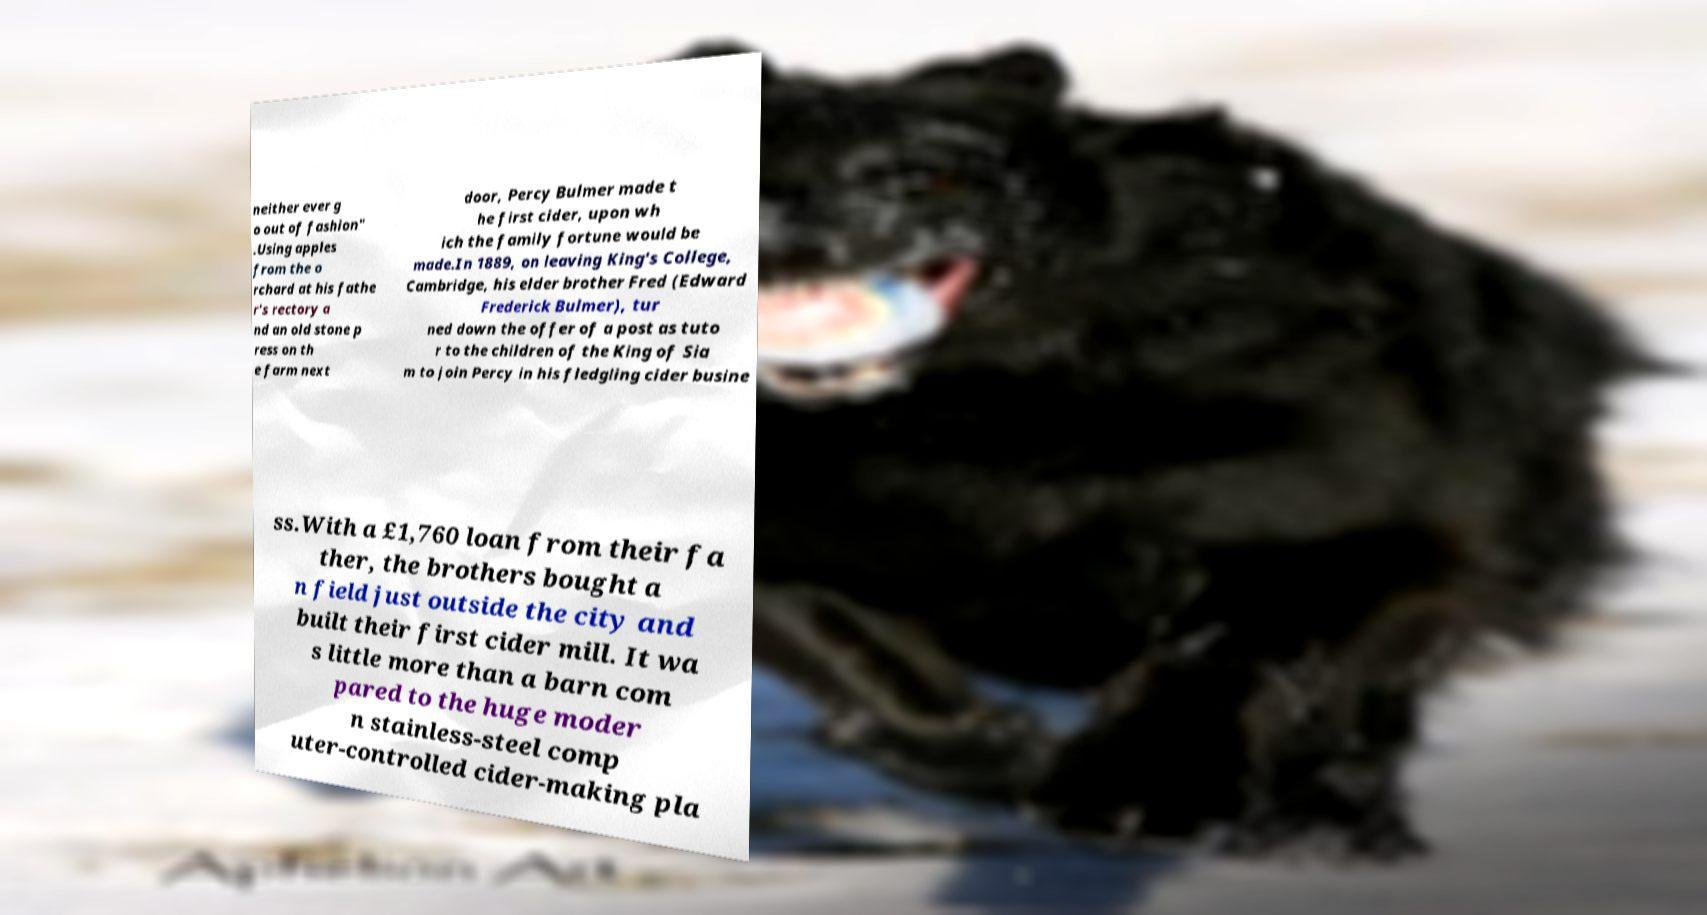For documentation purposes, I need the text within this image transcribed. Could you provide that? neither ever g o out of fashion" .Using apples from the o rchard at his fathe r's rectory a nd an old stone p ress on th e farm next door, Percy Bulmer made t he first cider, upon wh ich the family fortune would be made.In 1889, on leaving King's College, Cambridge, his elder brother Fred (Edward Frederick Bulmer), tur ned down the offer of a post as tuto r to the children of the King of Sia m to join Percy in his fledgling cider busine ss.With a £1,760 loan from their fa ther, the brothers bought a n field just outside the city and built their first cider mill. It wa s little more than a barn com pared to the huge moder n stainless-steel comp uter-controlled cider-making pla 